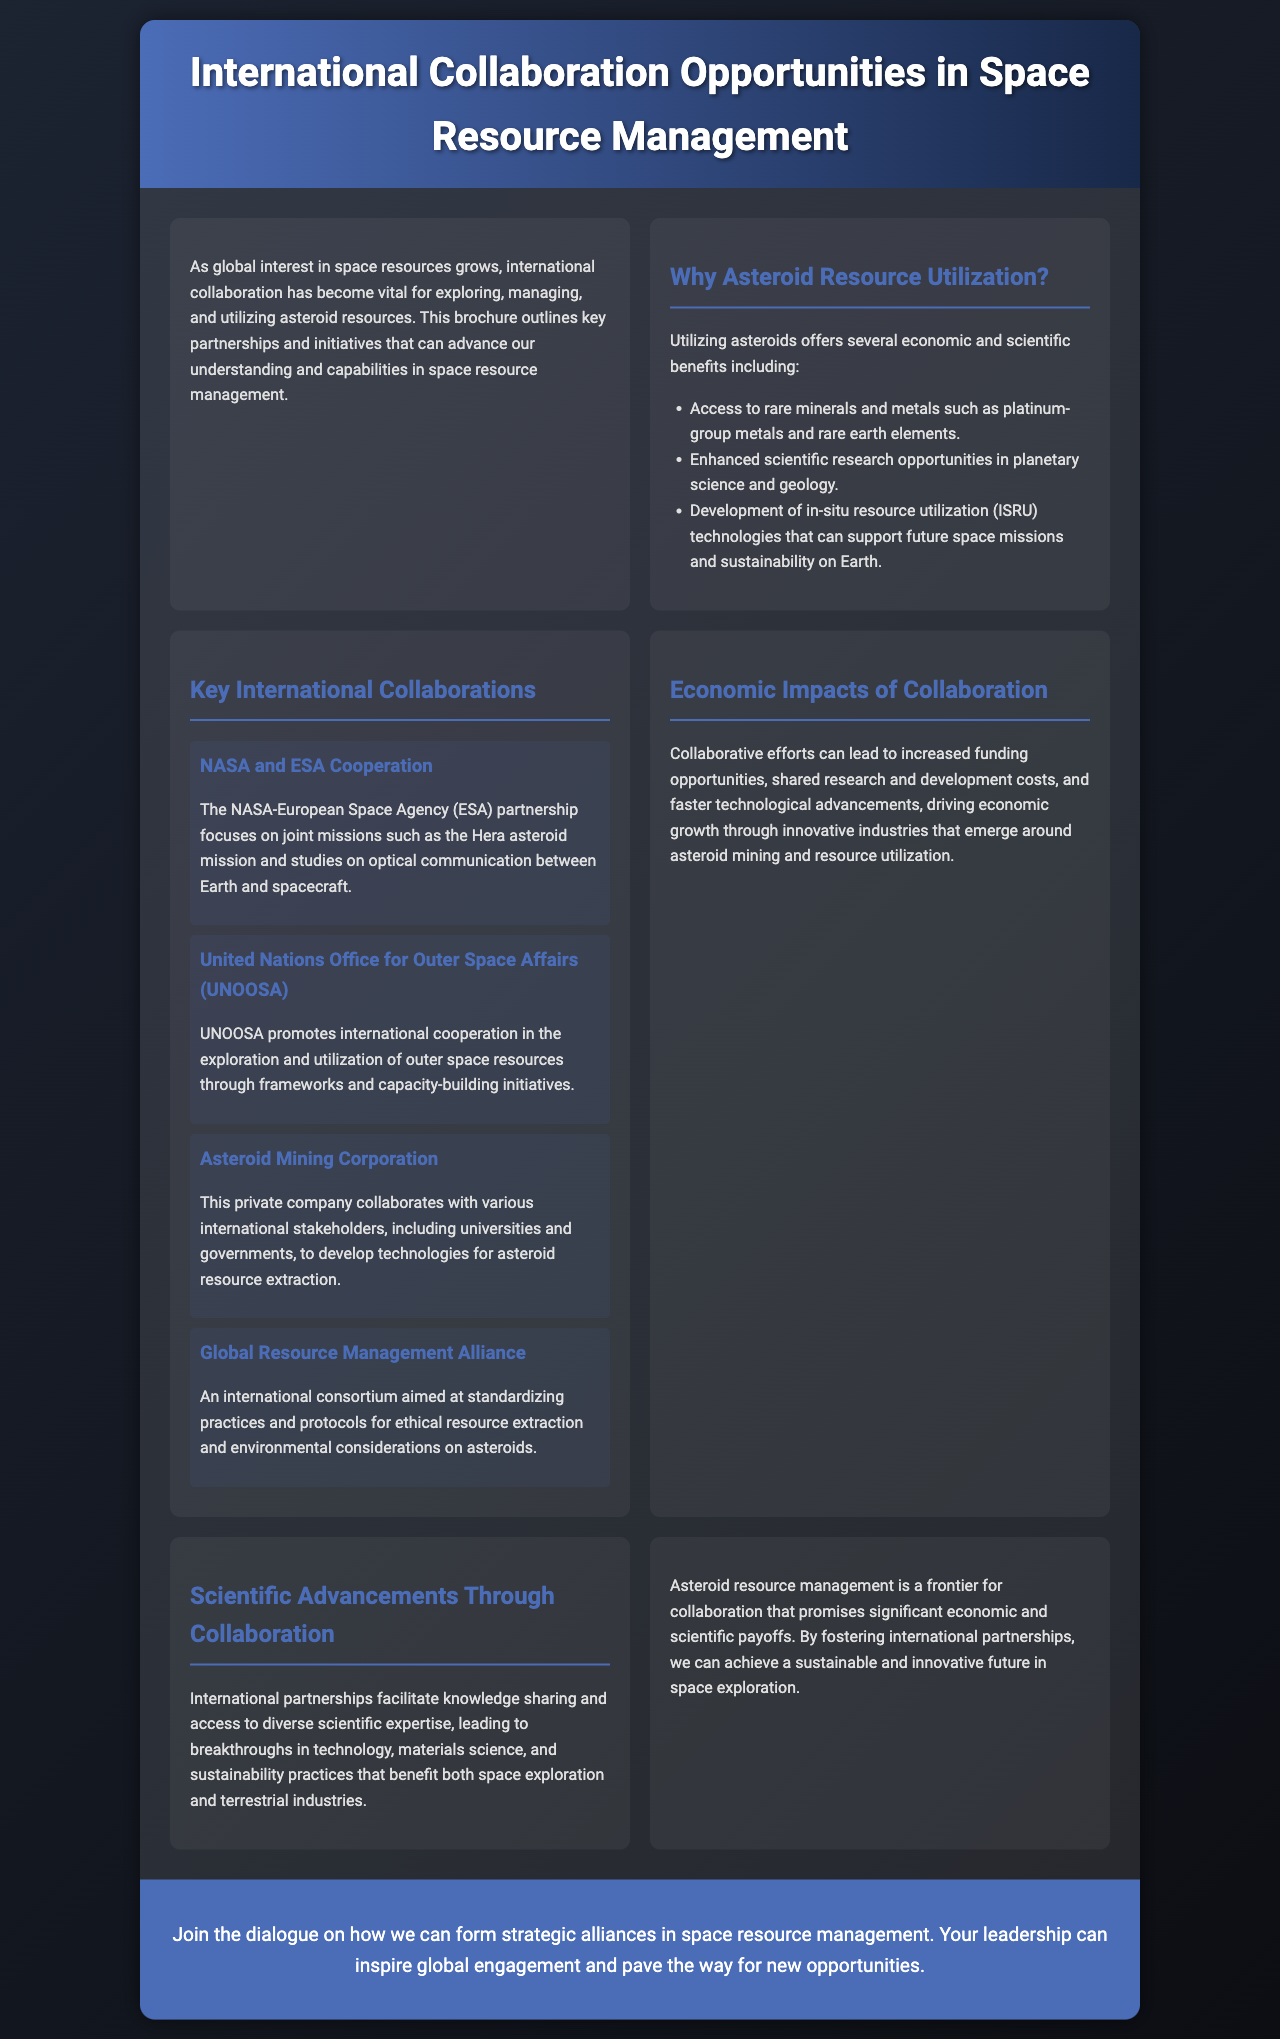What is the title of the brochure? The title is prominently displayed at the top of the document, indicating the main focus on collaboration in space resource management.
Answer: International Collaboration Opportunities in Space Resource Management What are examples of rare minerals accessed through asteroid resource utilization? Specific types of rare minerals are listed in the document as key benefits of asteroid resource utilization.
Answer: Platinum-group metals and rare earth elements What is the name of the mission associated with NASA and ESA? The document mentions a joint mission between NASA and ESA, highlighting a specific collaboration effort.
Answer: Hera asteroid mission Which organization promotes international cooperation in outer space resources? The document identifies a key organization responsible for encouraging collaboration in space exploration and resource utilization.
Answer: United Nations Office for Outer Space Affairs (UNOOSA) What is one of the economic impacts of collaboration mentioned? The brochure states key benefits that stem from international collaboration in space resource management which contribute to economic growth.
Answer: Increased funding opportunities What type of alliance aims to standardize ethical extraction practices? The document describes a consortium that focuses on ethical standards for resource extraction, indicating its purpose.
Answer: Global Resource Management Alliance How many main collaborations are described in the brochure? By counting the listed collaborations in a section of the document, you can determine the total number presented.
Answer: Four What is one scientific benefit of international partnerships? The document highlights a specific advantage that arises from joint efforts in space resource management.
Answer: Breakthroughs in technology 